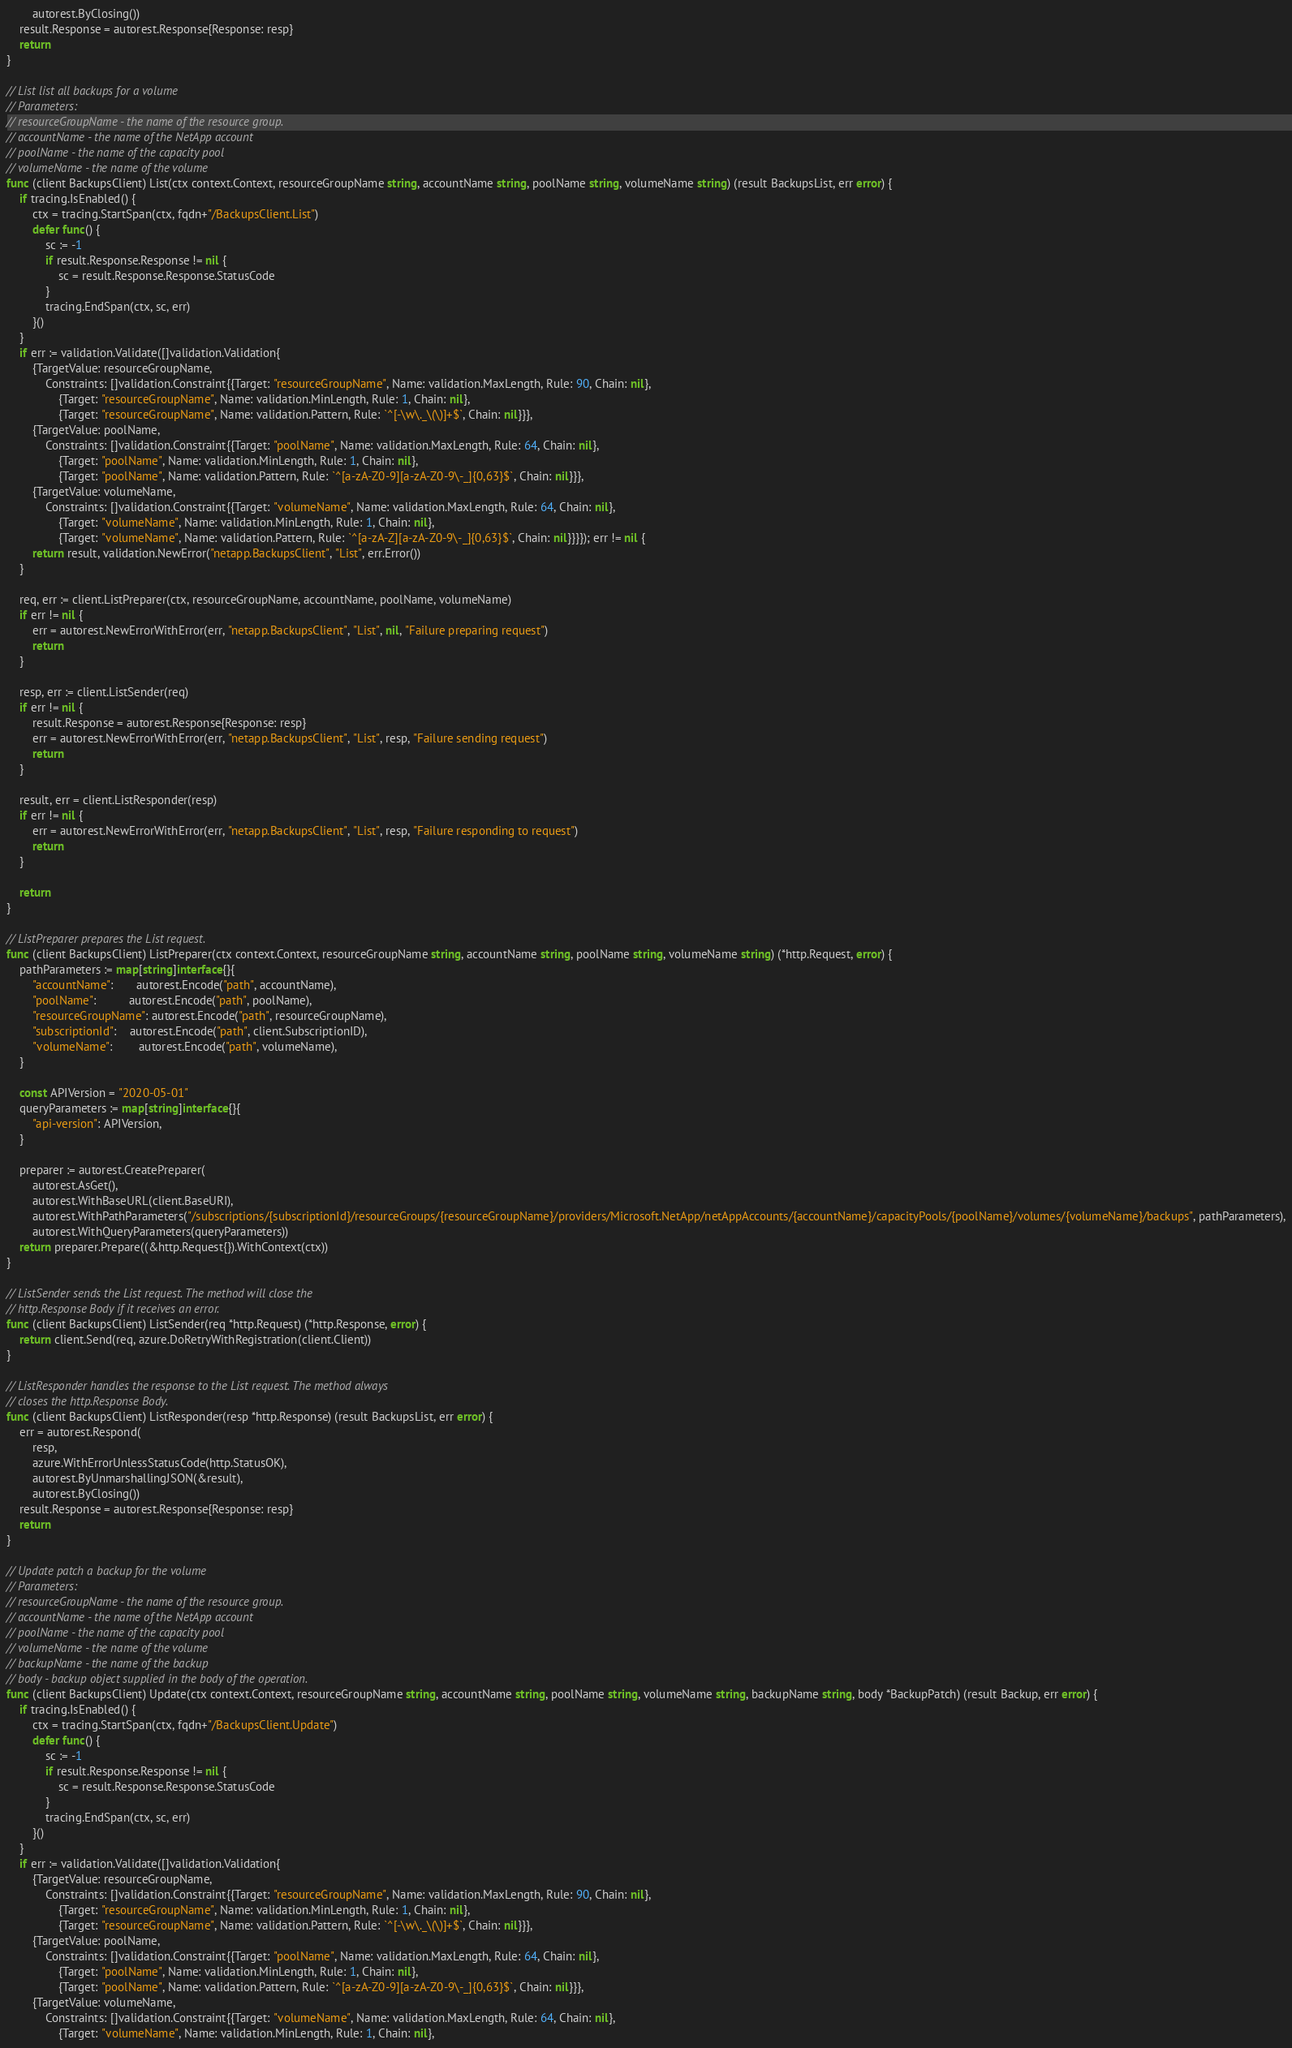<code> <loc_0><loc_0><loc_500><loc_500><_Go_>		autorest.ByClosing())
	result.Response = autorest.Response{Response: resp}
	return
}

// List list all backups for a volume
// Parameters:
// resourceGroupName - the name of the resource group.
// accountName - the name of the NetApp account
// poolName - the name of the capacity pool
// volumeName - the name of the volume
func (client BackupsClient) List(ctx context.Context, resourceGroupName string, accountName string, poolName string, volumeName string) (result BackupsList, err error) {
	if tracing.IsEnabled() {
		ctx = tracing.StartSpan(ctx, fqdn+"/BackupsClient.List")
		defer func() {
			sc := -1
			if result.Response.Response != nil {
				sc = result.Response.Response.StatusCode
			}
			tracing.EndSpan(ctx, sc, err)
		}()
	}
	if err := validation.Validate([]validation.Validation{
		{TargetValue: resourceGroupName,
			Constraints: []validation.Constraint{{Target: "resourceGroupName", Name: validation.MaxLength, Rule: 90, Chain: nil},
				{Target: "resourceGroupName", Name: validation.MinLength, Rule: 1, Chain: nil},
				{Target: "resourceGroupName", Name: validation.Pattern, Rule: `^[-\w\._\(\)]+$`, Chain: nil}}},
		{TargetValue: poolName,
			Constraints: []validation.Constraint{{Target: "poolName", Name: validation.MaxLength, Rule: 64, Chain: nil},
				{Target: "poolName", Name: validation.MinLength, Rule: 1, Chain: nil},
				{Target: "poolName", Name: validation.Pattern, Rule: `^[a-zA-Z0-9][a-zA-Z0-9\-_]{0,63}$`, Chain: nil}}},
		{TargetValue: volumeName,
			Constraints: []validation.Constraint{{Target: "volumeName", Name: validation.MaxLength, Rule: 64, Chain: nil},
				{Target: "volumeName", Name: validation.MinLength, Rule: 1, Chain: nil},
				{Target: "volumeName", Name: validation.Pattern, Rule: `^[a-zA-Z][a-zA-Z0-9\-_]{0,63}$`, Chain: nil}}}}); err != nil {
		return result, validation.NewError("netapp.BackupsClient", "List", err.Error())
	}

	req, err := client.ListPreparer(ctx, resourceGroupName, accountName, poolName, volumeName)
	if err != nil {
		err = autorest.NewErrorWithError(err, "netapp.BackupsClient", "List", nil, "Failure preparing request")
		return
	}

	resp, err := client.ListSender(req)
	if err != nil {
		result.Response = autorest.Response{Response: resp}
		err = autorest.NewErrorWithError(err, "netapp.BackupsClient", "List", resp, "Failure sending request")
		return
	}

	result, err = client.ListResponder(resp)
	if err != nil {
		err = autorest.NewErrorWithError(err, "netapp.BackupsClient", "List", resp, "Failure responding to request")
		return
	}

	return
}

// ListPreparer prepares the List request.
func (client BackupsClient) ListPreparer(ctx context.Context, resourceGroupName string, accountName string, poolName string, volumeName string) (*http.Request, error) {
	pathParameters := map[string]interface{}{
		"accountName":       autorest.Encode("path", accountName),
		"poolName":          autorest.Encode("path", poolName),
		"resourceGroupName": autorest.Encode("path", resourceGroupName),
		"subscriptionId":    autorest.Encode("path", client.SubscriptionID),
		"volumeName":        autorest.Encode("path", volumeName),
	}

	const APIVersion = "2020-05-01"
	queryParameters := map[string]interface{}{
		"api-version": APIVersion,
	}

	preparer := autorest.CreatePreparer(
		autorest.AsGet(),
		autorest.WithBaseURL(client.BaseURI),
		autorest.WithPathParameters("/subscriptions/{subscriptionId}/resourceGroups/{resourceGroupName}/providers/Microsoft.NetApp/netAppAccounts/{accountName}/capacityPools/{poolName}/volumes/{volumeName}/backups", pathParameters),
		autorest.WithQueryParameters(queryParameters))
	return preparer.Prepare((&http.Request{}).WithContext(ctx))
}

// ListSender sends the List request. The method will close the
// http.Response Body if it receives an error.
func (client BackupsClient) ListSender(req *http.Request) (*http.Response, error) {
	return client.Send(req, azure.DoRetryWithRegistration(client.Client))
}

// ListResponder handles the response to the List request. The method always
// closes the http.Response Body.
func (client BackupsClient) ListResponder(resp *http.Response) (result BackupsList, err error) {
	err = autorest.Respond(
		resp,
		azure.WithErrorUnlessStatusCode(http.StatusOK),
		autorest.ByUnmarshallingJSON(&result),
		autorest.ByClosing())
	result.Response = autorest.Response{Response: resp}
	return
}

// Update patch a backup for the volume
// Parameters:
// resourceGroupName - the name of the resource group.
// accountName - the name of the NetApp account
// poolName - the name of the capacity pool
// volumeName - the name of the volume
// backupName - the name of the backup
// body - backup object supplied in the body of the operation.
func (client BackupsClient) Update(ctx context.Context, resourceGroupName string, accountName string, poolName string, volumeName string, backupName string, body *BackupPatch) (result Backup, err error) {
	if tracing.IsEnabled() {
		ctx = tracing.StartSpan(ctx, fqdn+"/BackupsClient.Update")
		defer func() {
			sc := -1
			if result.Response.Response != nil {
				sc = result.Response.Response.StatusCode
			}
			tracing.EndSpan(ctx, sc, err)
		}()
	}
	if err := validation.Validate([]validation.Validation{
		{TargetValue: resourceGroupName,
			Constraints: []validation.Constraint{{Target: "resourceGroupName", Name: validation.MaxLength, Rule: 90, Chain: nil},
				{Target: "resourceGroupName", Name: validation.MinLength, Rule: 1, Chain: nil},
				{Target: "resourceGroupName", Name: validation.Pattern, Rule: `^[-\w\._\(\)]+$`, Chain: nil}}},
		{TargetValue: poolName,
			Constraints: []validation.Constraint{{Target: "poolName", Name: validation.MaxLength, Rule: 64, Chain: nil},
				{Target: "poolName", Name: validation.MinLength, Rule: 1, Chain: nil},
				{Target: "poolName", Name: validation.Pattern, Rule: `^[a-zA-Z0-9][a-zA-Z0-9\-_]{0,63}$`, Chain: nil}}},
		{TargetValue: volumeName,
			Constraints: []validation.Constraint{{Target: "volumeName", Name: validation.MaxLength, Rule: 64, Chain: nil},
				{Target: "volumeName", Name: validation.MinLength, Rule: 1, Chain: nil},</code> 